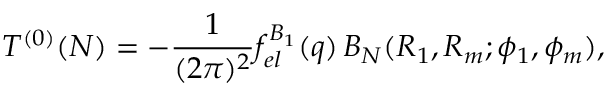<formula> <loc_0><loc_0><loc_500><loc_500>T ^ { ( 0 ) } ( N ) = - \frac { 1 } { ( 2 \pi ) ^ { 2 } } f _ { e l } ^ { B _ { 1 } } ( q ) \, B _ { N } ( R _ { 1 } , R _ { m } ; \phi _ { 1 } , \phi _ { m } ) ,</formula> 